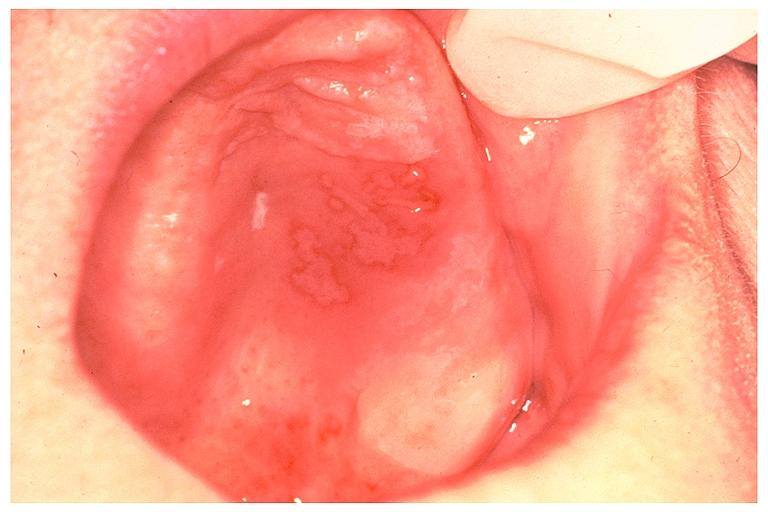what is present?
Answer the question using a single word or phrase. Oral 